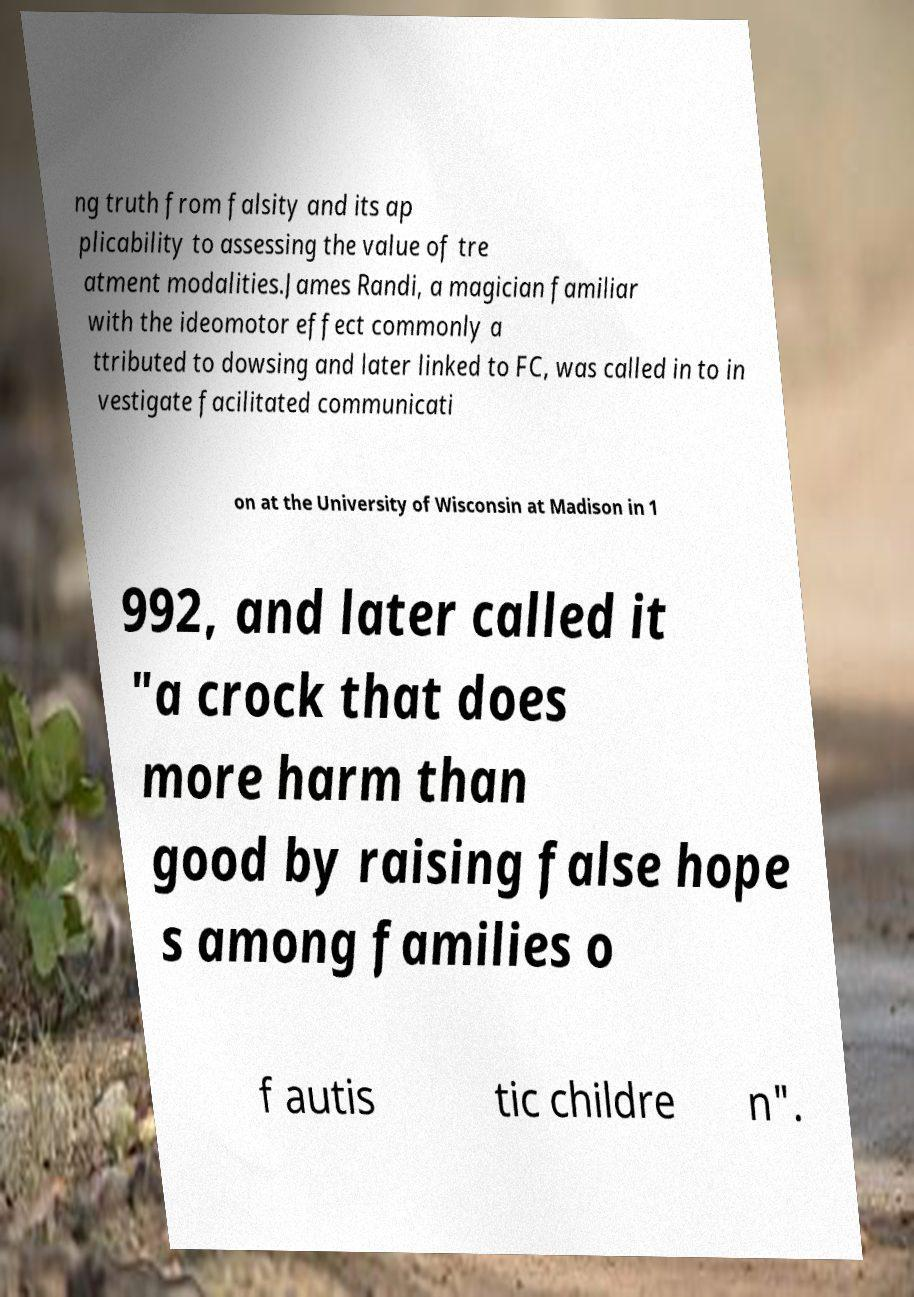Please read and relay the text visible in this image. What does it say? ng truth from falsity and its ap plicability to assessing the value of tre atment modalities.James Randi, a magician familiar with the ideomotor effect commonly a ttributed to dowsing and later linked to FC, was called in to in vestigate facilitated communicati on at the University of Wisconsin at Madison in 1 992, and later called it "a crock that does more harm than good by raising false hope s among families o f autis tic childre n". 